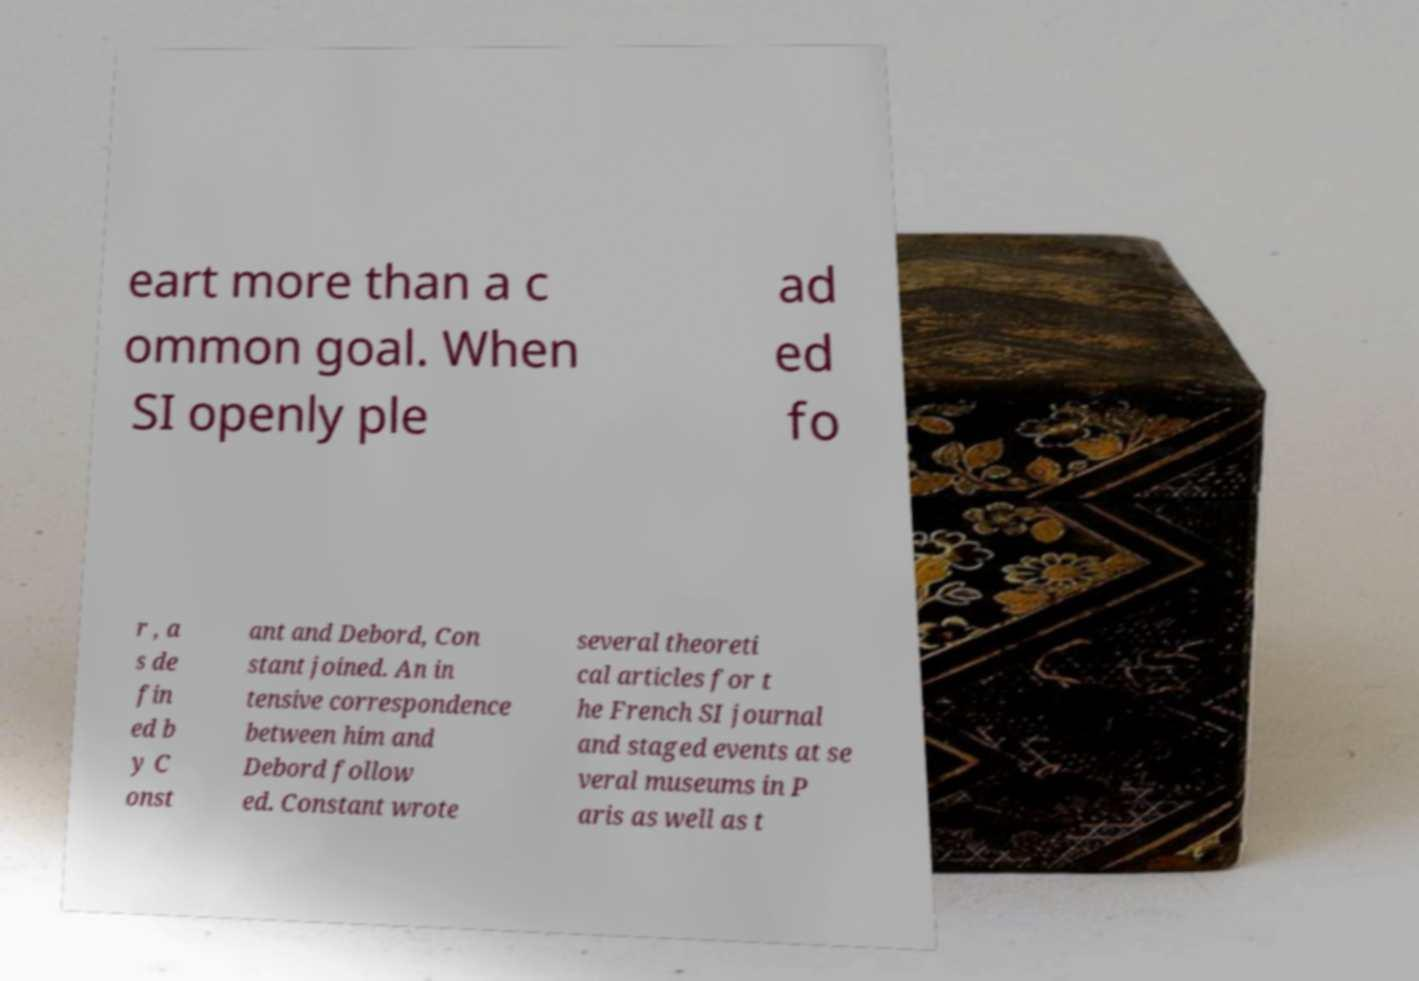For documentation purposes, I need the text within this image transcribed. Could you provide that? eart more than a c ommon goal. When SI openly ple ad ed fo r , a s de fin ed b y C onst ant and Debord, Con stant joined. An in tensive correspondence between him and Debord follow ed. Constant wrote several theoreti cal articles for t he French SI journal and staged events at se veral museums in P aris as well as t 